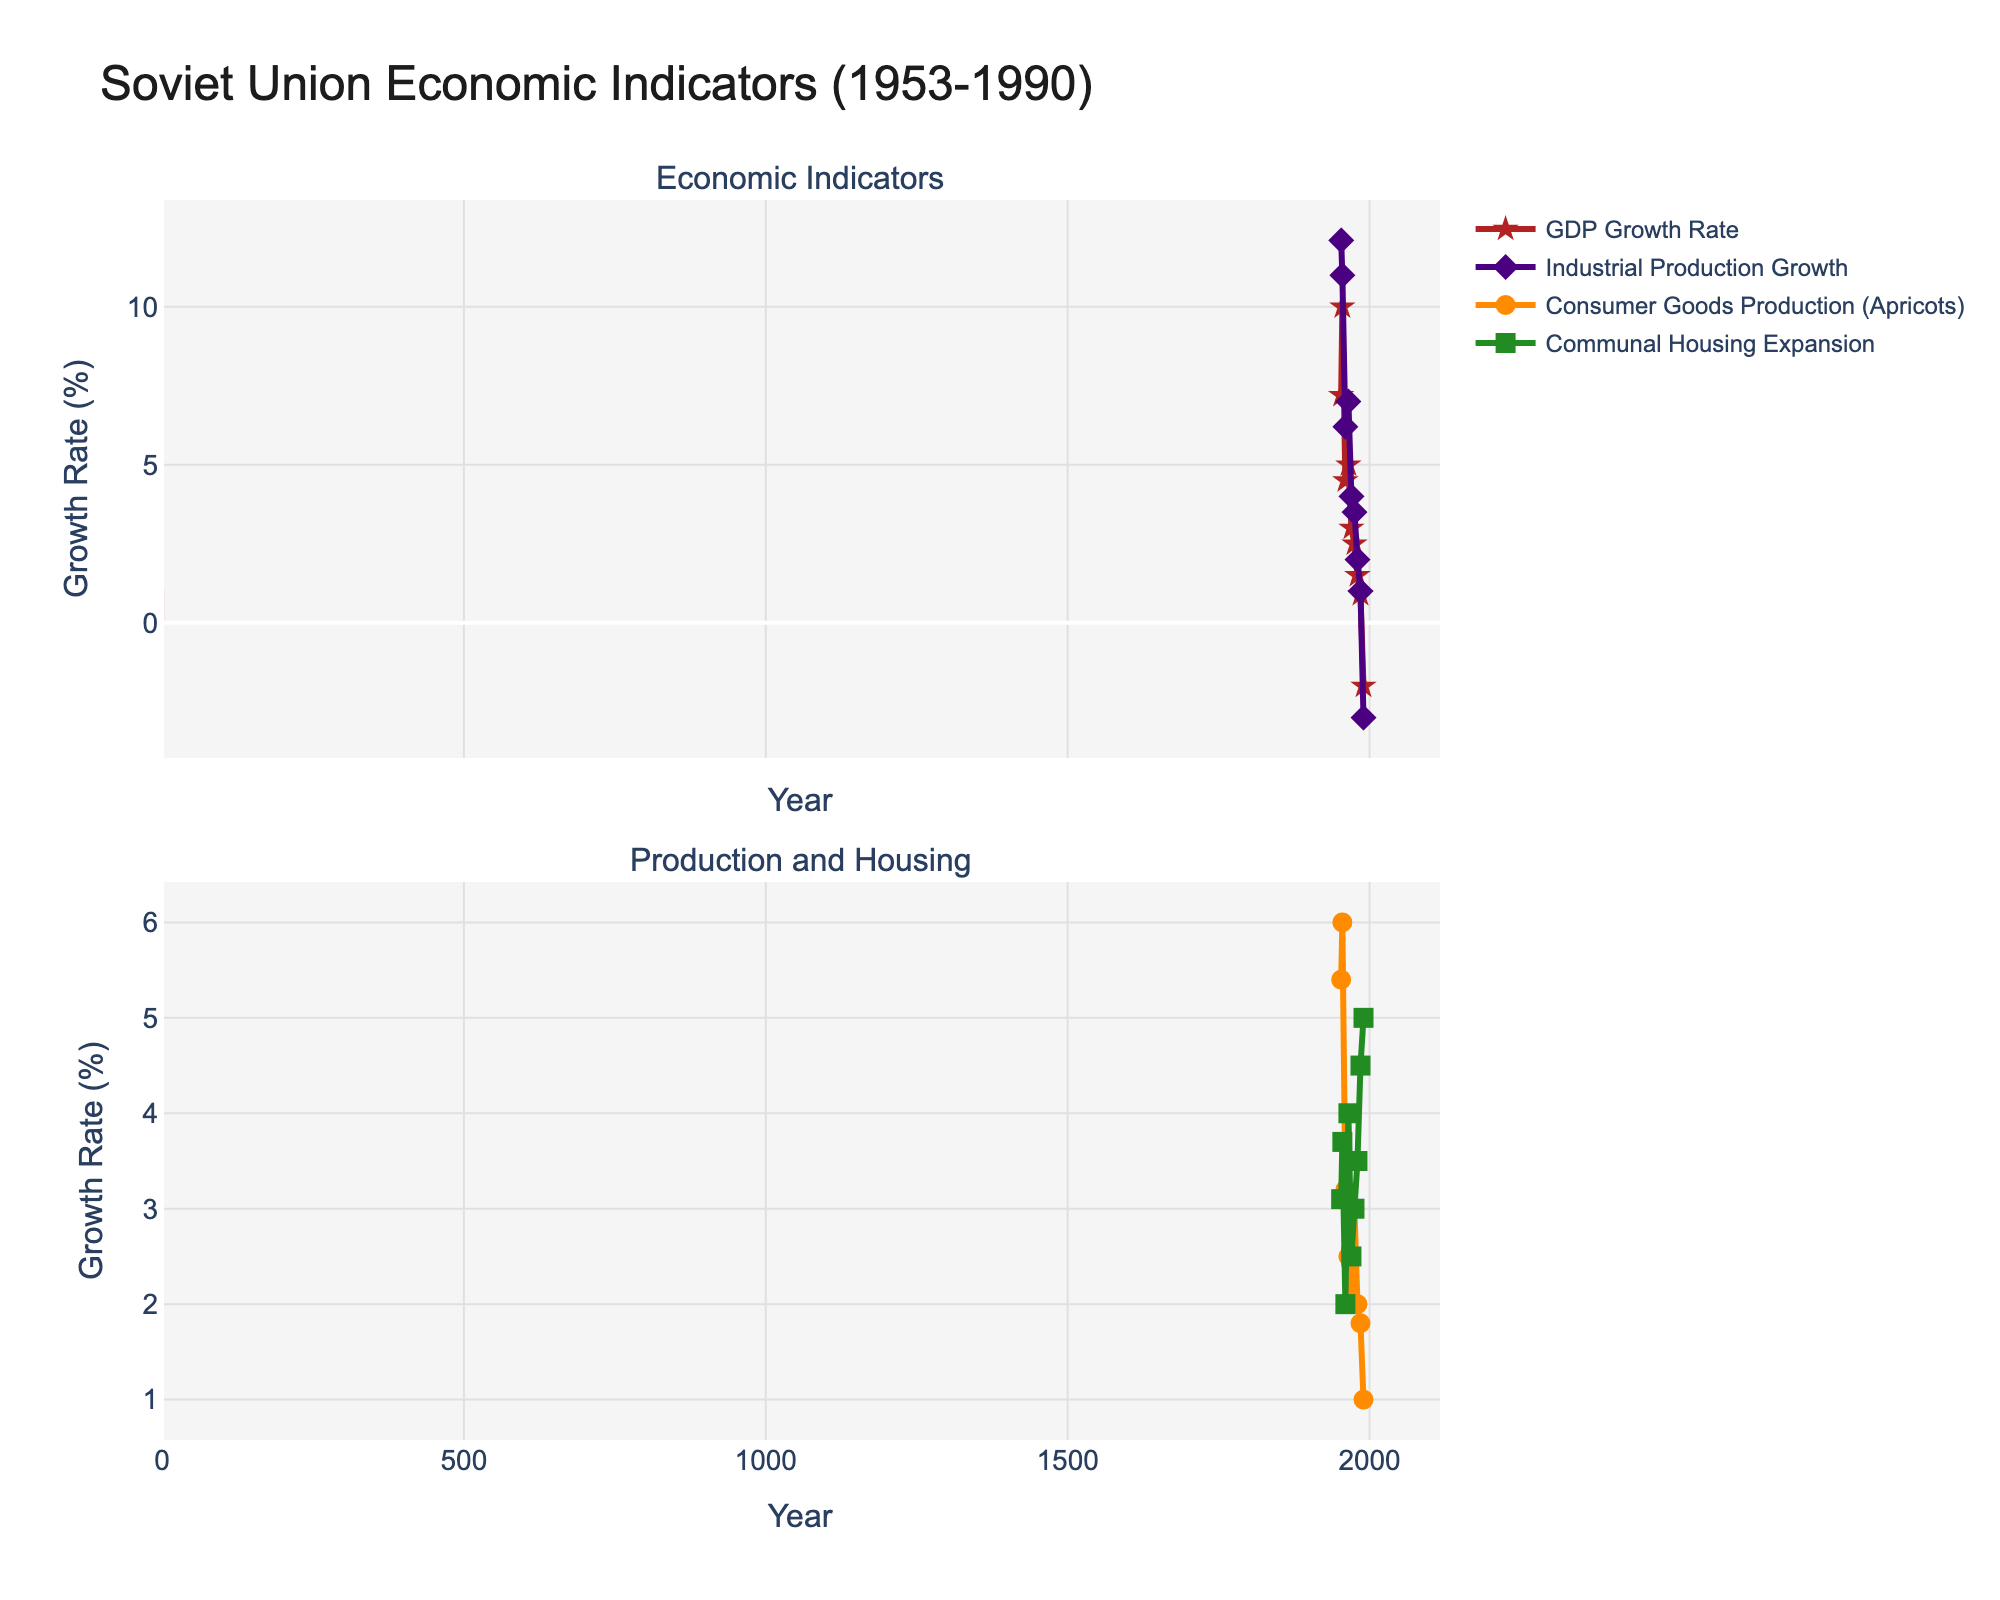What is the overall trend of the GDP growth rate from 1953 to 1990? The GDP growth rate shows a clear declining trend over the years, starting at 7.2% in 1953, peaking at 10.0% in 1955, and gradually decreasing to negative values by 1990.
Answer: Declining trend How did the industrial production growth rate change from 1953 to 1990? The industrial production growth rate starts high at 12.1% in 1953, then sees a gradual decline over the years, dropping steadily to -3.0% by 1990.
Answer: Decreasing trend Which year had the highest growth in communal housing expansion? Looking at the communal housing expansion data, the highest growth rate is in 1990 at 5%.
Answer: 1990 Was the consumer goods production of apricots higher in 1960 or in 1980? In 1960, the consumer goods production of apricots was 3.2%, whereas in 1980, it was 2.0%.
Answer: 1960 What is the difference in GDP growth rate between 1955 and 1990? The GDP growth rate in 1955 was 10.0%, whereas in 1990 it was -2.0%. The difference is 10.0 - (-2.0) = 12.0%.
Answer: 12.0% Compare the industrial production growth rate in 1970 to the GDP growth rate in 1970. Which was higher? In 1970, the industrial production growth rate was 4.0%, and the GDP growth rate was 3.0%. The industrial production growth rate was higher.
Answer: Industrial production growth rate What is the average GDP growth rate from 1980 to 1990? The GDP growth rates for 1980, 1985, and 1990 are 1.5%, 0.9%, and -2.0% respectively. The average is (1.5 + 0.9 - 2.0) / 3 = 0.13%.
Answer: 0.13% Which year had the lowest consumer goods production of apricots? The lowest consumer goods production for apricots was 1.0% in 1990.
Answer: 1990 Was communal housing expansion consistently increasing, decreasing, or fluctuating over the years? The communal housing expansion shows an increasing trend from 3.1% in 1953 to 5.0% in 1990, with small fluctuations.
Answer: Increasing trend with fluctuations 